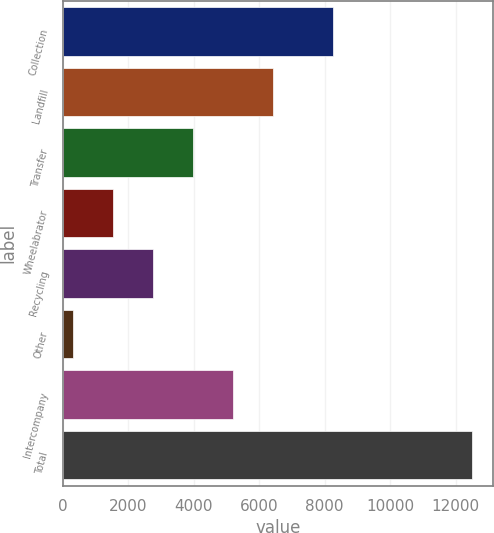Convert chart to OTSL. <chart><loc_0><loc_0><loc_500><loc_500><bar_chart><fcel>Collection<fcel>Landfill<fcel>Transfer<fcel>Wheelabrator<fcel>Recycling<fcel>Other<fcel>Intercompany<fcel>Total<nl><fcel>8247<fcel>6414.5<fcel>3974.3<fcel>1534.1<fcel>2754.2<fcel>314<fcel>5194.4<fcel>12515<nl></chart> 